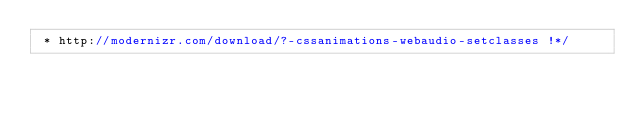Convert code to text. <code><loc_0><loc_0><loc_500><loc_500><_JavaScript_> * http://modernizr.com/download/?-cssanimations-webaudio-setclasses !*/</code> 